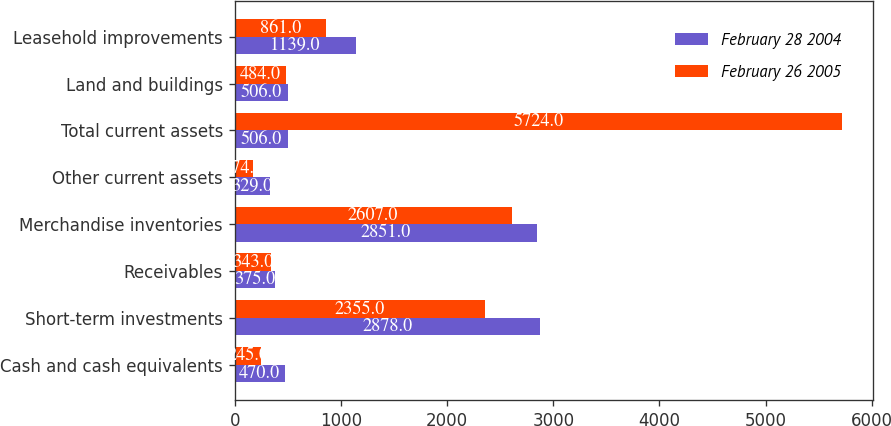<chart> <loc_0><loc_0><loc_500><loc_500><stacked_bar_chart><ecel><fcel>Cash and cash equivalents<fcel>Short-term investments<fcel>Receivables<fcel>Merchandise inventories<fcel>Other current assets<fcel>Total current assets<fcel>Land and buildings<fcel>Leasehold improvements<nl><fcel>February 28 2004<fcel>470<fcel>2878<fcel>375<fcel>2851<fcel>329<fcel>506<fcel>506<fcel>1139<nl><fcel>February 26 2005<fcel>245<fcel>2355<fcel>343<fcel>2607<fcel>174<fcel>5724<fcel>484<fcel>861<nl></chart> 